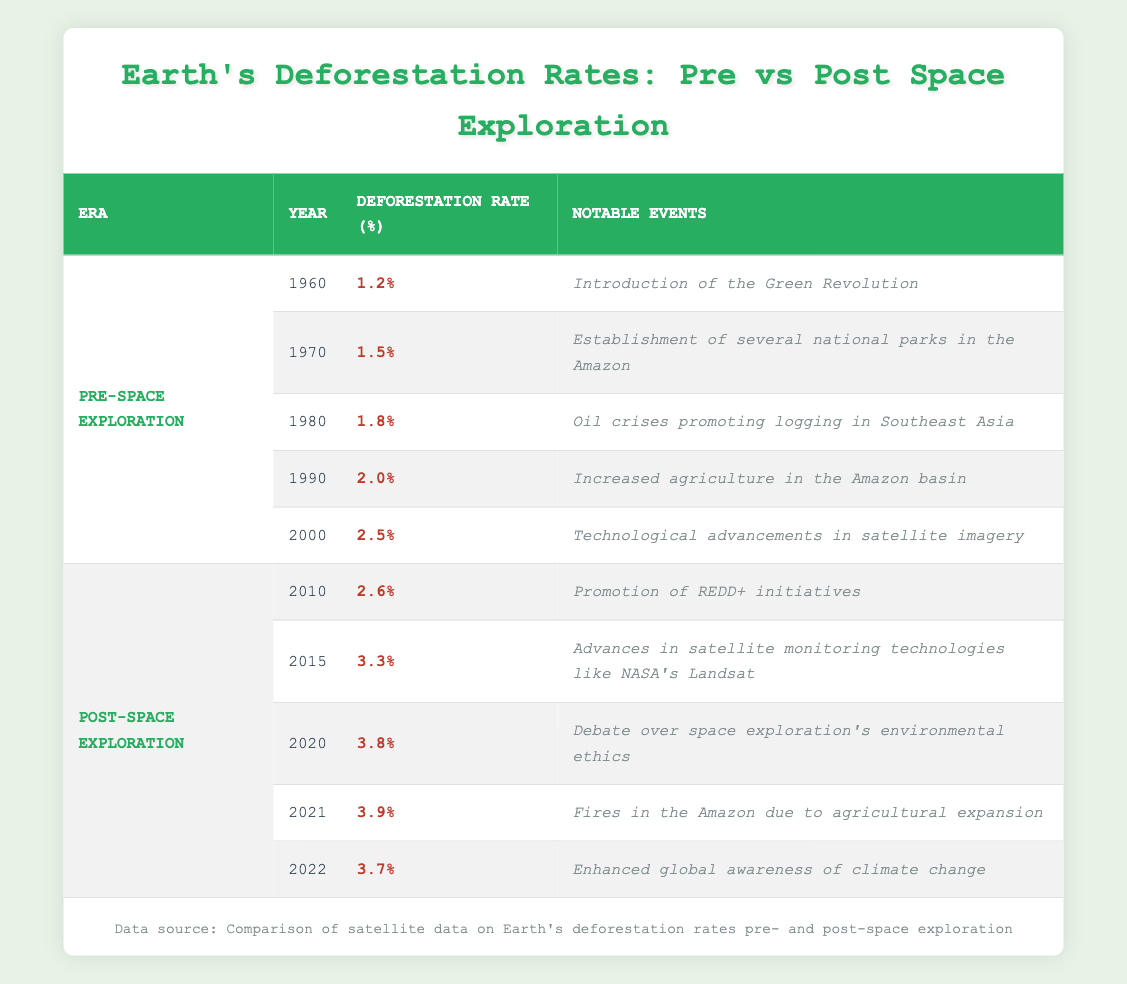What was the deforestation rate in 2000? The table shows that in the year 2000, the deforestation rate was listed as 2.5%.
Answer: 2.5% What notable event occurred in 2015? According to the table, the notable event in 2015 was advances in satellite monitoring technologies like NASA's Landsat.
Answer: Advances in satellite monitoring technologies like NASA's Landsat What was the increase in deforestation rate from 1990 to 2000? The deforestation rate in 1990 was 2.0% and in 2000 it was 2.5%. The increase can be calculated as 2.5% - 2.0% = 0.5%.
Answer: 0.5% Is it true that the deforestation rate decreased from 2021 to 2022? In the table, the deforestation rate in 2021 was 3.9% and in 2022 it was 3.7%, so it did decrease. Thus, the statement is true.
Answer: Yes What was the average deforestation rate during the pre-space exploration era? The deforestation rates for pre-space exploration years (1960, 1970, 1980, 1990, 2000) are 1.2%, 1.5%, 1.8%, 2.0%, and 2.5%. Adding these gives a total of 9.0%, and dividing by 5 (the number of years) gives an average of 1.8%.
Answer: 1.8% 